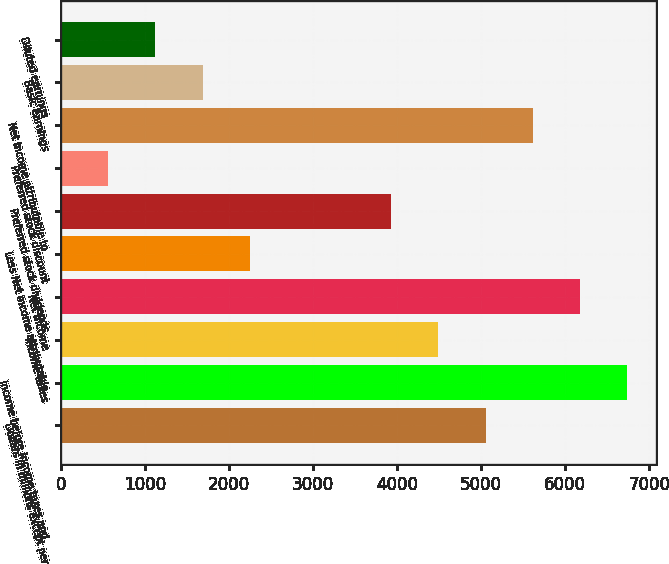<chart> <loc_0><loc_0><loc_500><loc_500><bar_chart><fcel>Dollars in millions except per<fcel>Income before income taxes and<fcel>Income taxes<fcel>Net income<fcel>Less Net income attributable<fcel>Preferred stock dividends<fcel>Preferred stock discount<fcel>Net income attributable to<fcel>Basic earnings<fcel>Diluted earnings<nl><fcel>5052.77<fcel>6736.4<fcel>4491.56<fcel>6175.19<fcel>2246.72<fcel>3930.35<fcel>563.09<fcel>5613.98<fcel>1685.51<fcel>1124.3<nl></chart> 